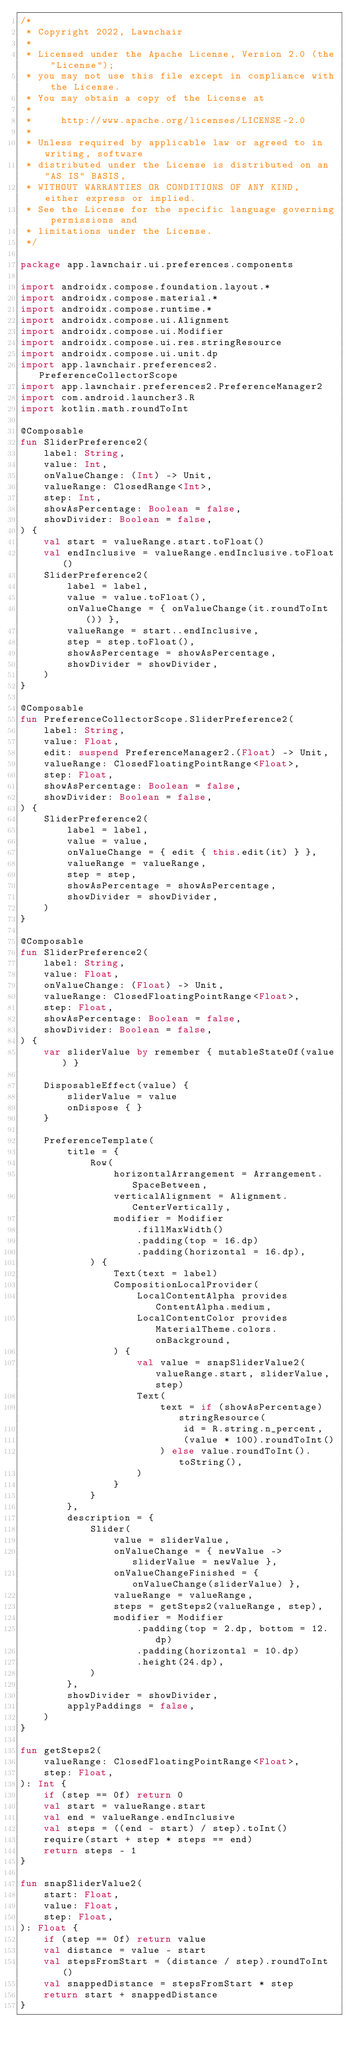<code> <loc_0><loc_0><loc_500><loc_500><_Kotlin_>/*
 * Copyright 2022, Lawnchair
 *
 * Licensed under the Apache License, Version 2.0 (the "License");
 * you may not use this file except in compliance with the License.
 * You may obtain a copy of the License at
 *
 *     http://www.apache.org/licenses/LICENSE-2.0
 *
 * Unless required by applicable law or agreed to in writing, software
 * distributed under the License is distributed on an "AS IS" BASIS,
 * WITHOUT WARRANTIES OR CONDITIONS OF ANY KIND, either express or implied.
 * See the License for the specific language governing permissions and
 * limitations under the License.
 */

package app.lawnchair.ui.preferences.components

import androidx.compose.foundation.layout.*
import androidx.compose.material.*
import androidx.compose.runtime.*
import androidx.compose.ui.Alignment
import androidx.compose.ui.Modifier
import androidx.compose.ui.res.stringResource
import androidx.compose.ui.unit.dp
import app.lawnchair.preferences2.PreferenceCollectorScope
import app.lawnchair.preferences2.PreferenceManager2
import com.android.launcher3.R
import kotlin.math.roundToInt

@Composable
fun SliderPreference2(
    label: String,
    value: Int,
    onValueChange: (Int) -> Unit,
    valueRange: ClosedRange<Int>,
    step: Int,
    showAsPercentage: Boolean = false,
    showDivider: Boolean = false,
) {
    val start = valueRange.start.toFloat()
    val endInclusive = valueRange.endInclusive.toFloat()
    SliderPreference2(
        label = label,
        value = value.toFloat(),
        onValueChange = { onValueChange(it.roundToInt()) },
        valueRange = start..endInclusive,
        step = step.toFloat(),
        showAsPercentage = showAsPercentage,
        showDivider = showDivider,
    )
}

@Composable
fun PreferenceCollectorScope.SliderPreference2(
    label: String,
    value: Float,
    edit: suspend PreferenceManager2.(Float) -> Unit,
    valueRange: ClosedFloatingPointRange<Float>,
    step: Float,
    showAsPercentage: Boolean = false,
    showDivider: Boolean = false,
) {
    SliderPreference2(
        label = label,
        value = value,
        onValueChange = { edit { this.edit(it) } },
        valueRange = valueRange,
        step = step,
        showAsPercentage = showAsPercentage,
        showDivider = showDivider,
    )
}

@Composable
fun SliderPreference2(
    label: String,
    value: Float,
    onValueChange: (Float) -> Unit,
    valueRange: ClosedFloatingPointRange<Float>,
    step: Float,
    showAsPercentage: Boolean = false,
    showDivider: Boolean = false,
) {
    var sliderValue by remember { mutableStateOf(value) }

    DisposableEffect(value) {
        sliderValue = value
        onDispose { }
    }

    PreferenceTemplate(
        title = {
            Row(
                horizontalArrangement = Arrangement.SpaceBetween,
                verticalAlignment = Alignment.CenterVertically,
                modifier = Modifier
                    .fillMaxWidth()
                    .padding(top = 16.dp)
                    .padding(horizontal = 16.dp),
            ) {
                Text(text = label)
                CompositionLocalProvider(
                    LocalContentAlpha provides ContentAlpha.medium,
                    LocalContentColor provides MaterialTheme.colors.onBackground,
                ) {
                    val value = snapSliderValue2(valueRange.start, sliderValue, step)
                    Text(
                        text = if (showAsPercentage) stringResource(
                            id = R.string.n_percent,
                            (value * 100).roundToInt()
                        ) else value.roundToInt().toString(),
                    )
                }
            }
        },
        description = {
            Slider(
                value = sliderValue,
                onValueChange = { newValue -> sliderValue = newValue },
                onValueChangeFinished = { onValueChange(sliderValue) },
                valueRange = valueRange,
                steps = getSteps2(valueRange, step),
                modifier = Modifier
                    .padding(top = 2.dp, bottom = 12.dp)
                    .padding(horizontal = 10.dp)
                    .height(24.dp),
            )
        },
        showDivider = showDivider,
        applyPaddings = false,
    )
}

fun getSteps2(
    valueRange: ClosedFloatingPointRange<Float>,
    step: Float,
): Int {
    if (step == 0f) return 0
    val start = valueRange.start
    val end = valueRange.endInclusive
    val steps = ((end - start) / step).toInt()
    require(start + step * steps == end)
    return steps - 1
}

fun snapSliderValue2(
    start: Float,
    value: Float,
    step: Float,
): Float {
    if (step == 0f) return value
    val distance = value - start
    val stepsFromStart = (distance / step).roundToInt()
    val snappedDistance = stepsFromStart * step
    return start + snappedDistance
}
</code> 